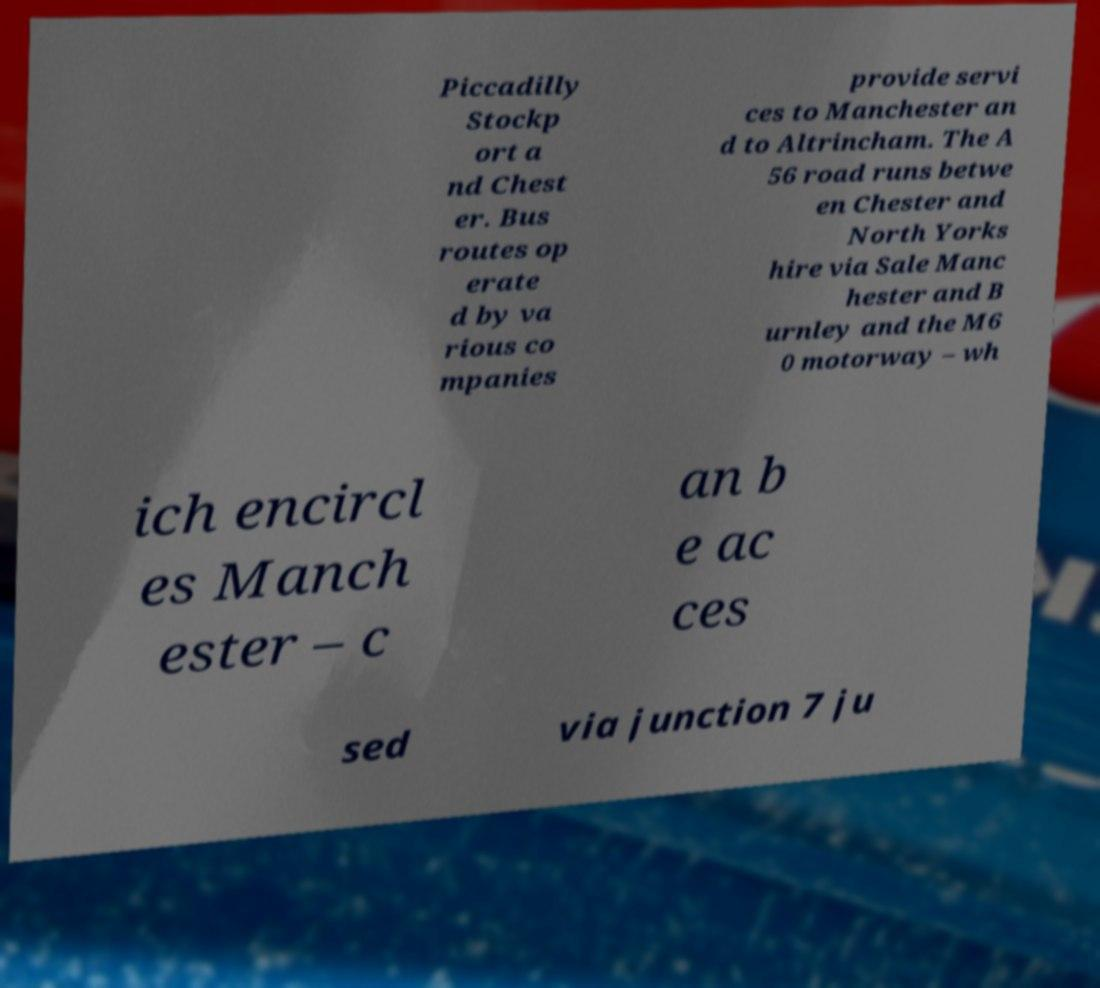What messages or text are displayed in this image? I need them in a readable, typed format. Piccadilly Stockp ort a nd Chest er. Bus routes op erate d by va rious co mpanies provide servi ces to Manchester an d to Altrincham. The A 56 road runs betwe en Chester and North Yorks hire via Sale Manc hester and B urnley and the M6 0 motorway – wh ich encircl es Manch ester – c an b e ac ces sed via junction 7 ju 